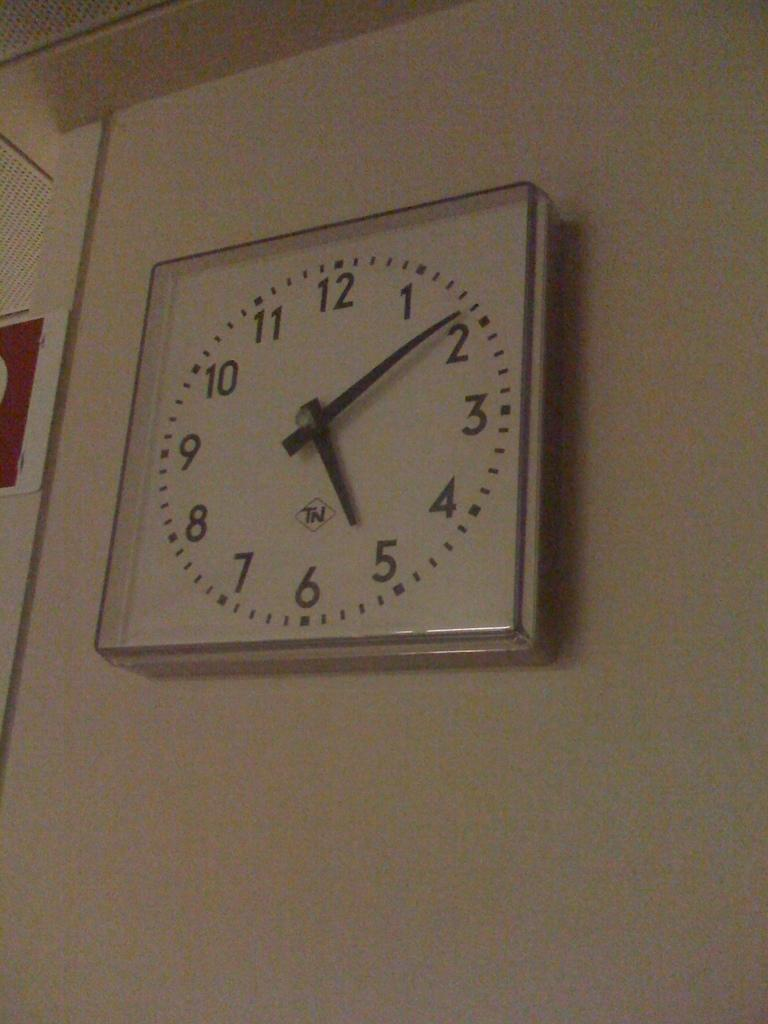<image>
Share a concise interpretation of the image provided. A white clock with TN on it hangs on a plain white wall 